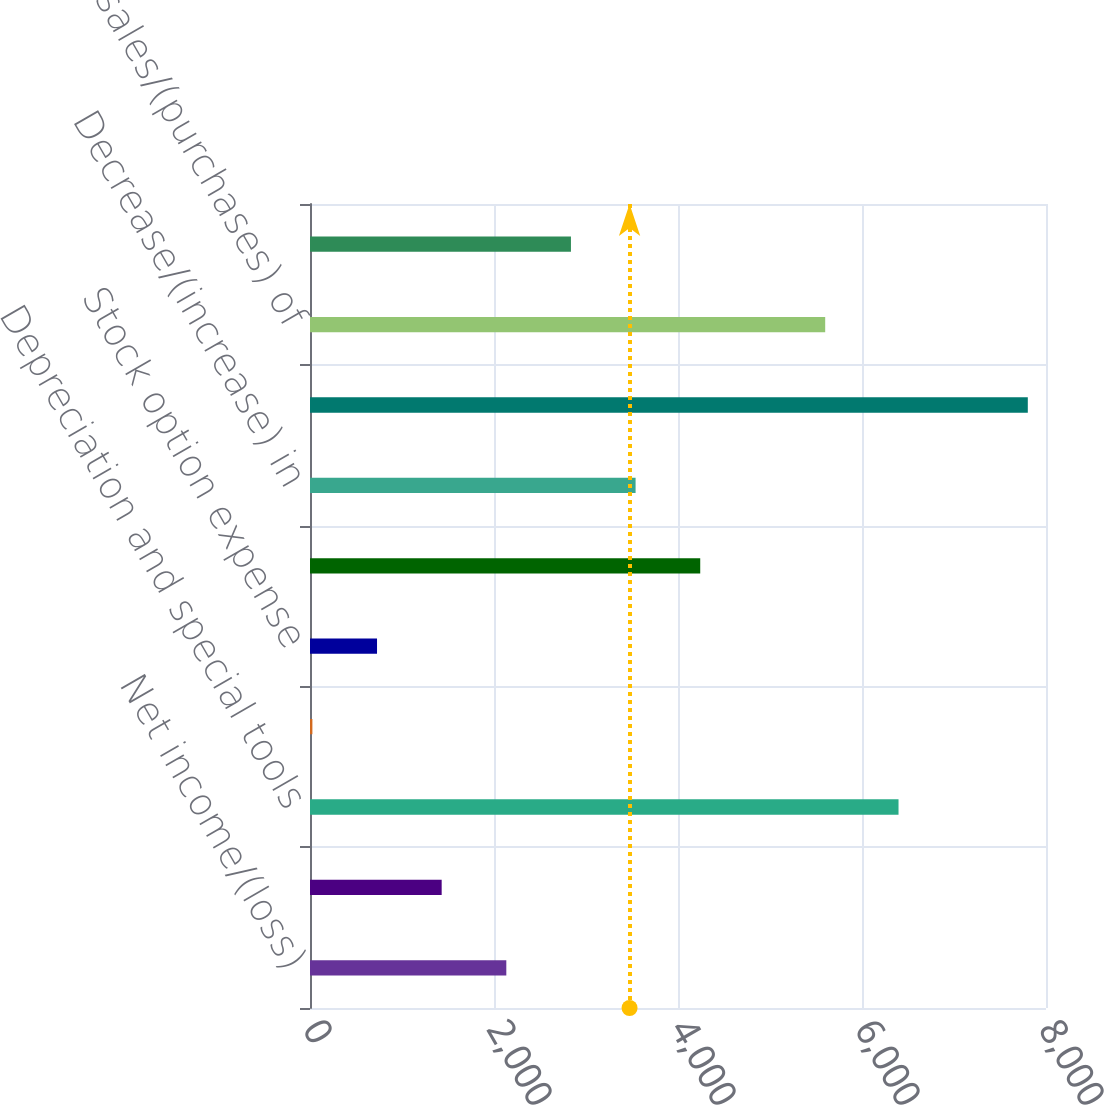Convert chart to OTSL. <chart><loc_0><loc_0><loc_500><loc_500><bar_chart><fcel>Net income/(loss)<fcel>(Income)/loss of discontinued<fcel>Depreciation and special tools<fcel>Amortization of intangibles<fcel>Stock option expense<fcel>Provision for deferred income<fcel>Decrease/(increase) in<fcel>Increase/(decrease) in<fcel>Net sales/(purchases) of<fcel>Other<nl><fcel>2133.8<fcel>1431.2<fcel>6397<fcel>26<fcel>728.6<fcel>4241.6<fcel>3539<fcel>7802.2<fcel>5600<fcel>2836.4<nl></chart> 